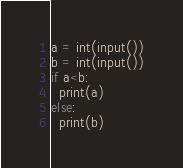<code> <loc_0><loc_0><loc_500><loc_500><_Python_>a = int(input())
b = int(input())
if a<b:
  print(a)
else:
  print(b)</code> 